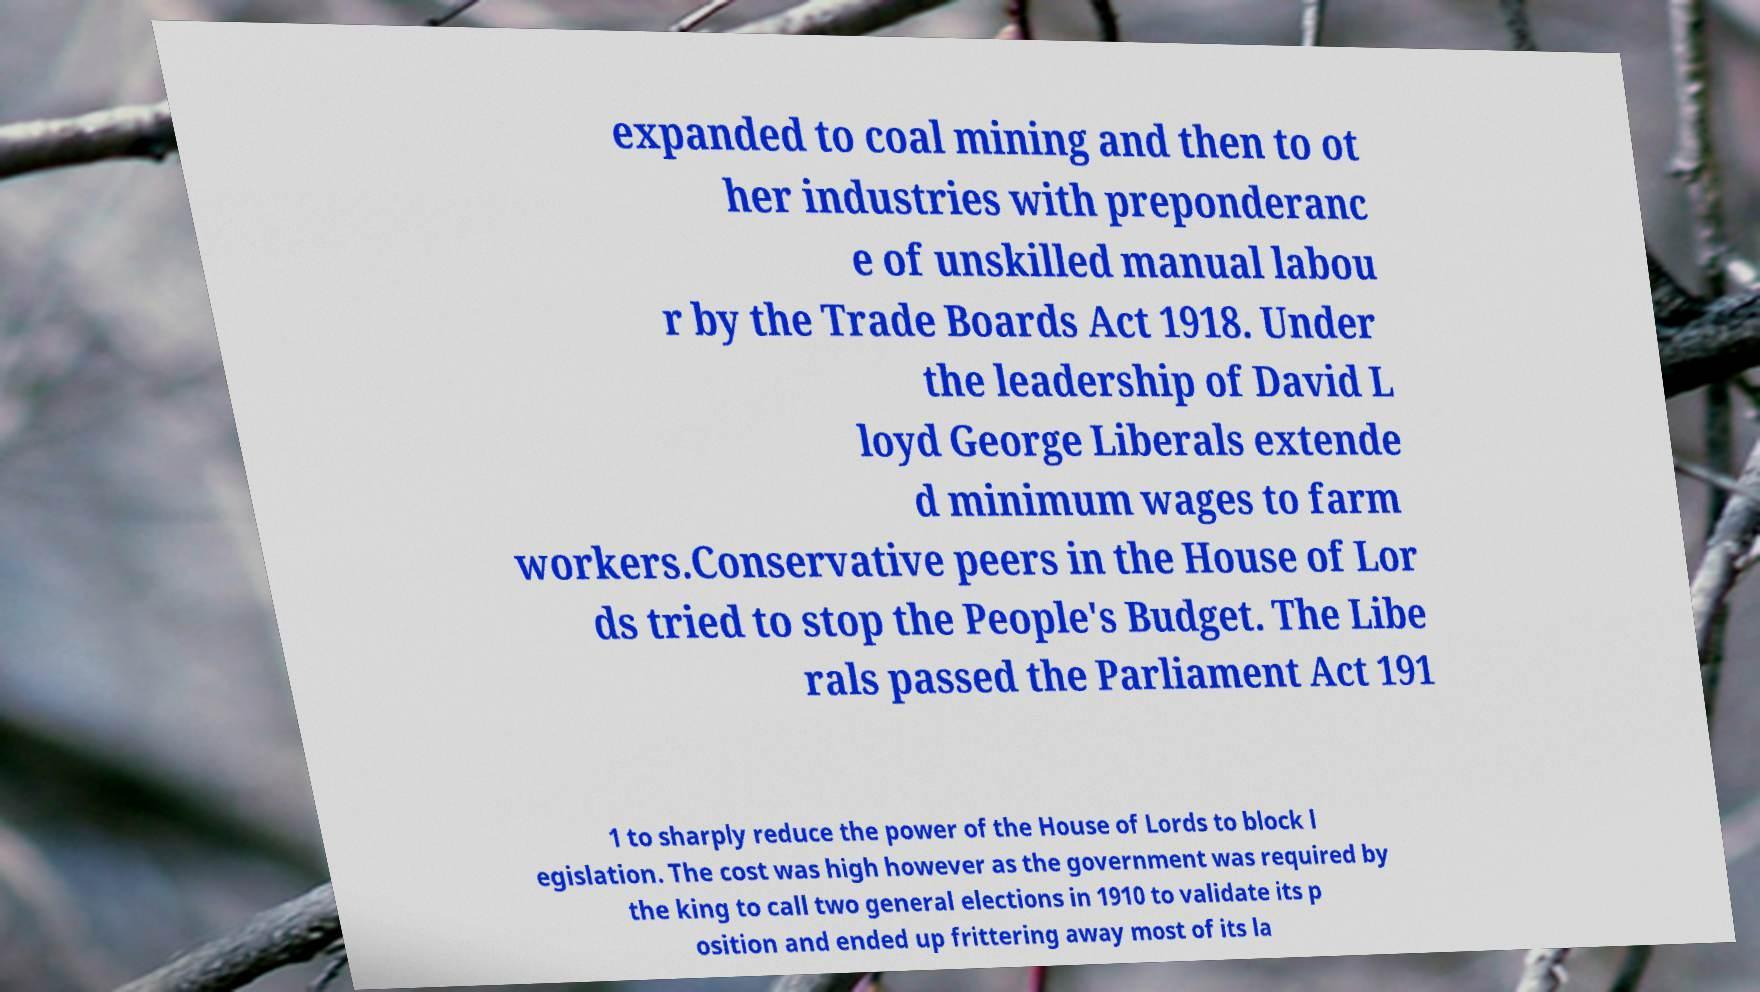What messages or text are displayed in this image? I need them in a readable, typed format. expanded to coal mining and then to ot her industries with preponderanc e of unskilled manual labou r by the Trade Boards Act 1918. Under the leadership of David L loyd George Liberals extende d minimum wages to farm workers.Conservative peers in the House of Lor ds tried to stop the People's Budget. The Libe rals passed the Parliament Act 191 1 to sharply reduce the power of the House of Lords to block l egislation. The cost was high however as the government was required by the king to call two general elections in 1910 to validate its p osition and ended up frittering away most of its la 